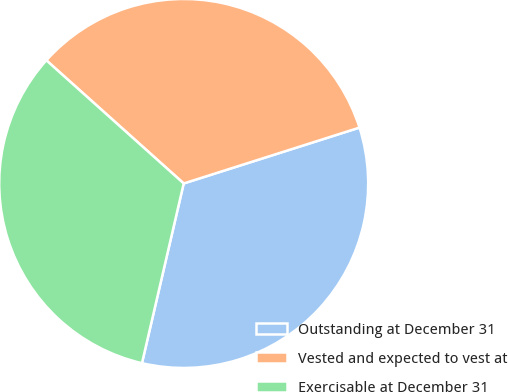Convert chart to OTSL. <chart><loc_0><loc_0><loc_500><loc_500><pie_chart><fcel>Outstanding at December 31<fcel>Vested and expected to vest at<fcel>Exercisable at December 31<nl><fcel>33.53%<fcel>33.47%<fcel>33.0%<nl></chart> 